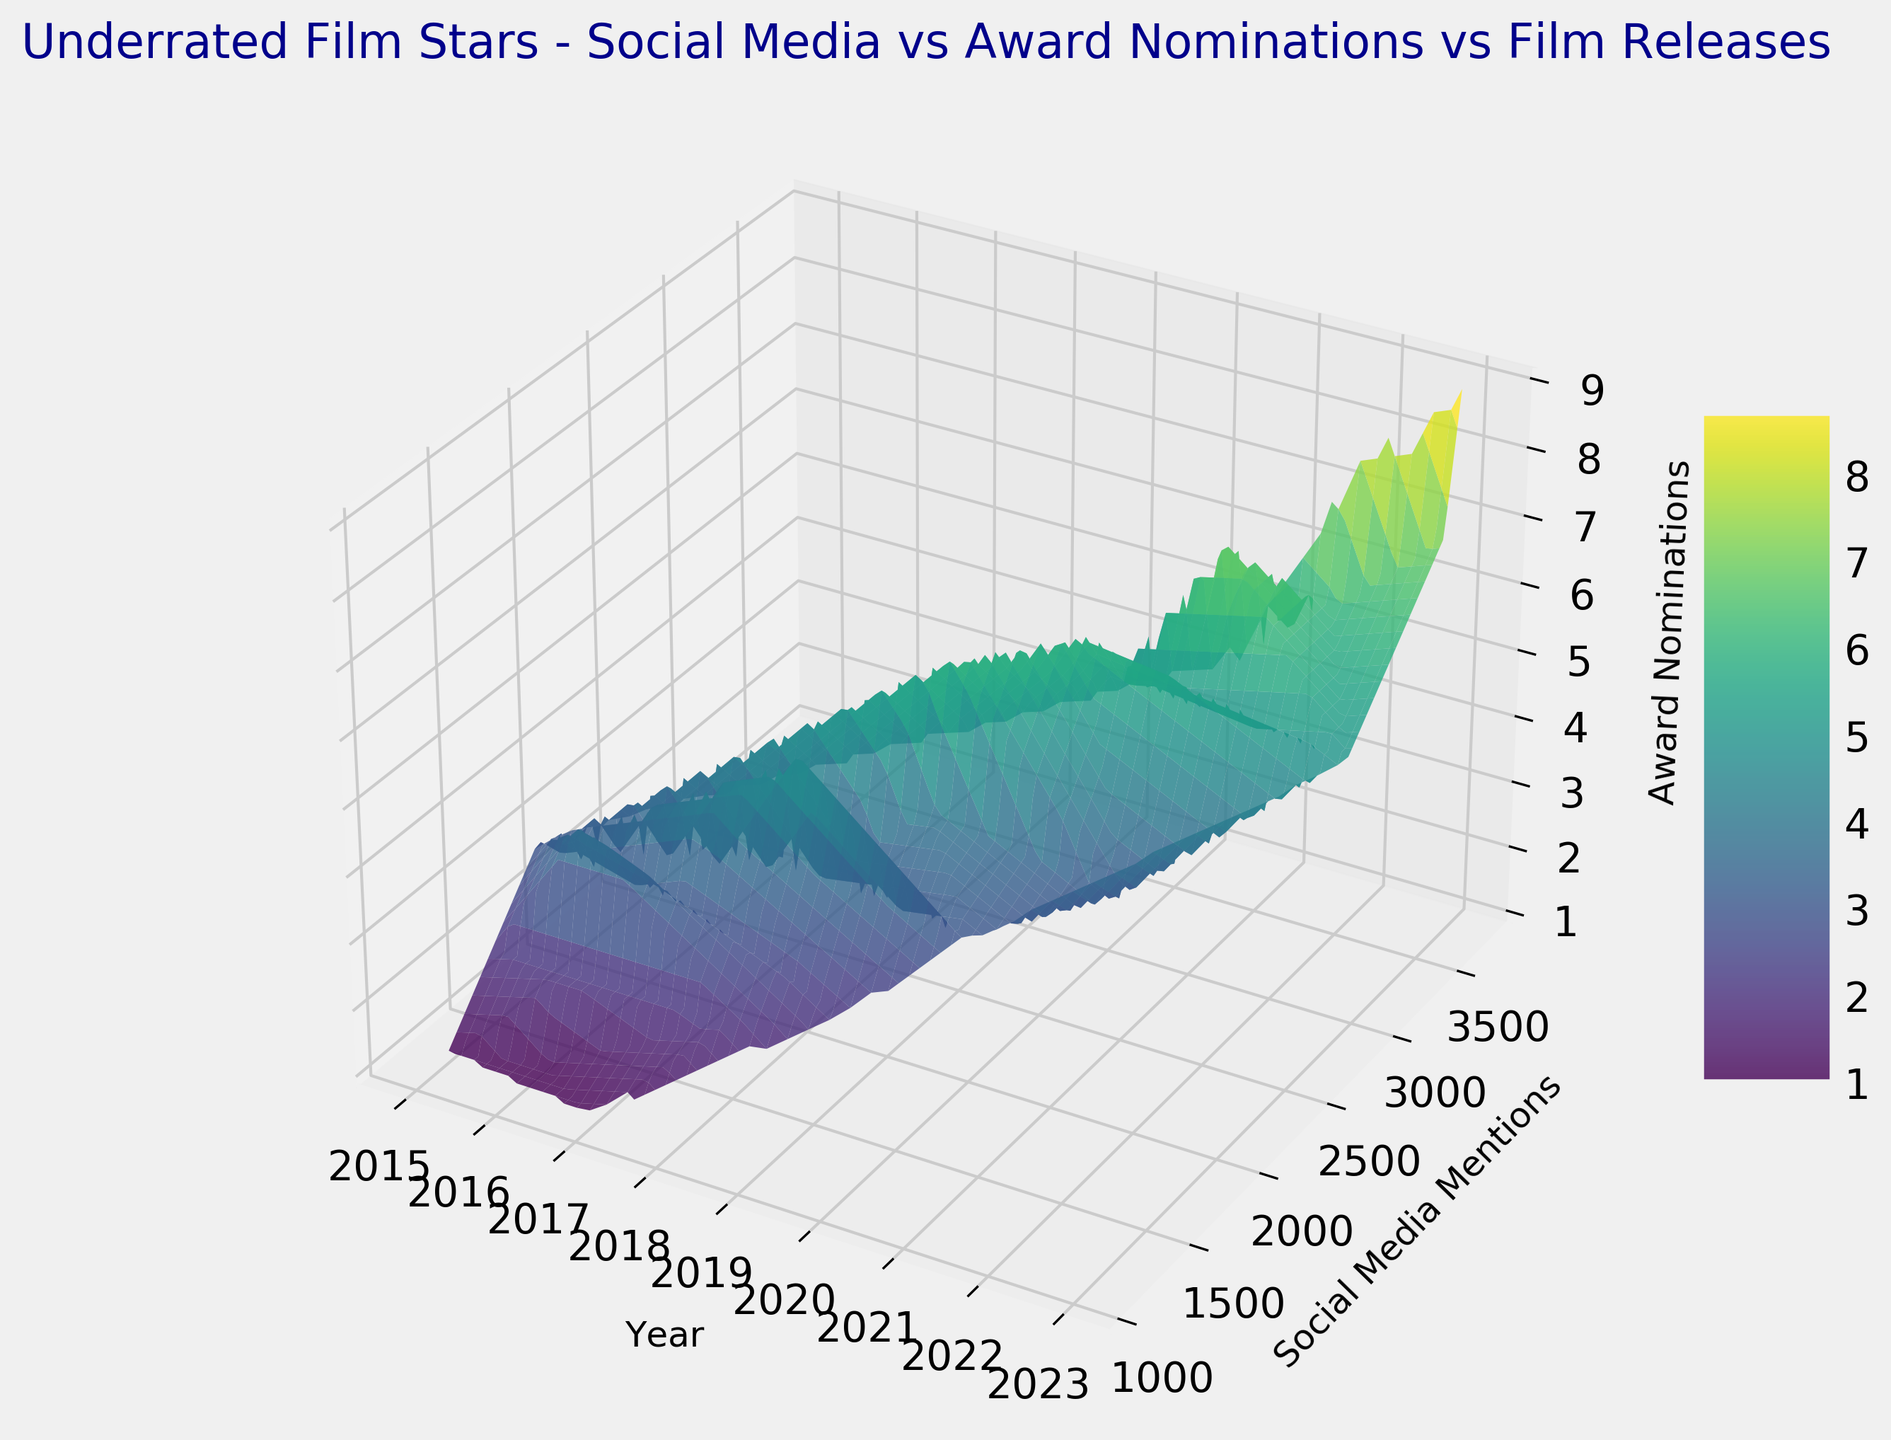What is the general trend in social media mentions over the years from 2015 to 2023? The 3D surface plot shows a consistent increase in social media mentions over the years. By visually inspecting the surface, the data points for social media mentions rise significantly from 2015 to 2023. This indicates that as time progresses, more social media mentions are recorded for these film stars.
Answer: Increasing trend Does an increase in social media mentions correspond with more award nominations? Inspecting the 3D surface, we see that the regions with higher social media mentions (closer to the upper-right corner) often are associated with higher award nominations (higher Z-axis values). This suggests a correlation where more social media mentions tend to associate with more award nominations.
Answer: Yes How does the number of award nominations change between the years 2020 and 2021? Focusing on the 2020 and 2021 sections of the 3D surface plot, we notice an increase in the height of the surface (Z-axis value) as we move from 2020 to 2021, indicating that the number of award nominations has increased from 2020 to 2021.
Answer: Increased Which year appears to have the highest peak in terms of award nominations, and what does this imply? By looking at the surface plot, the year 2023 has the highest peak on the Z-axis, indicating that this year had the most award nominations. This implies that the film stars had the most recognition in terms of award nominations in 2023.
Answer: 2023; implies highest recognition Are there any years where despite high social media mentions, there were low award nominations? Inspecting the 3D surface, we can see that in years like 2018 and 2019, there are regions where social media mentions are high, but the corresponding Z-axis (award nominations) values are relatively low compared to other years with similar social media mentions.
Answer: 2018 and 2019 How do social media mentions and award nominations in the year 2015 compare to 2020? Looking at the sections of the 3D plot for the years 2015 and 2020, we see that the surface for 2015 is relatively lower both in Y-axis (social media mentions) and Z-axis (award nominations) compared to the surface for 2020. This indicates that both social media mentions and award nominations were significantly lower in 2015 compared to 2020.
Answer: 2015: lower mentions and nominations, 2020: higher What pattern do you observe for the number of award nominations as social media mentions increase every year? Observing the 3D surface, generally, as we move along the Y-axis (social media mentions) from lower to higher values, the Z-axis (award nominations) also tends to increase. This pattern suggests that more social media mentions are often associated with more award nominations.
Answer: Increasing pattern What is the relationship between the year and the number of film releases per year? Although the plot primarily illustrates social media mentions and award nominations, the year versus film releases data suggests an increasing trend in film releases as well as we move from 2015 to 2023, consistent with the increasing trends in social media mentions and award nominations.
Answer: Increasing trend 